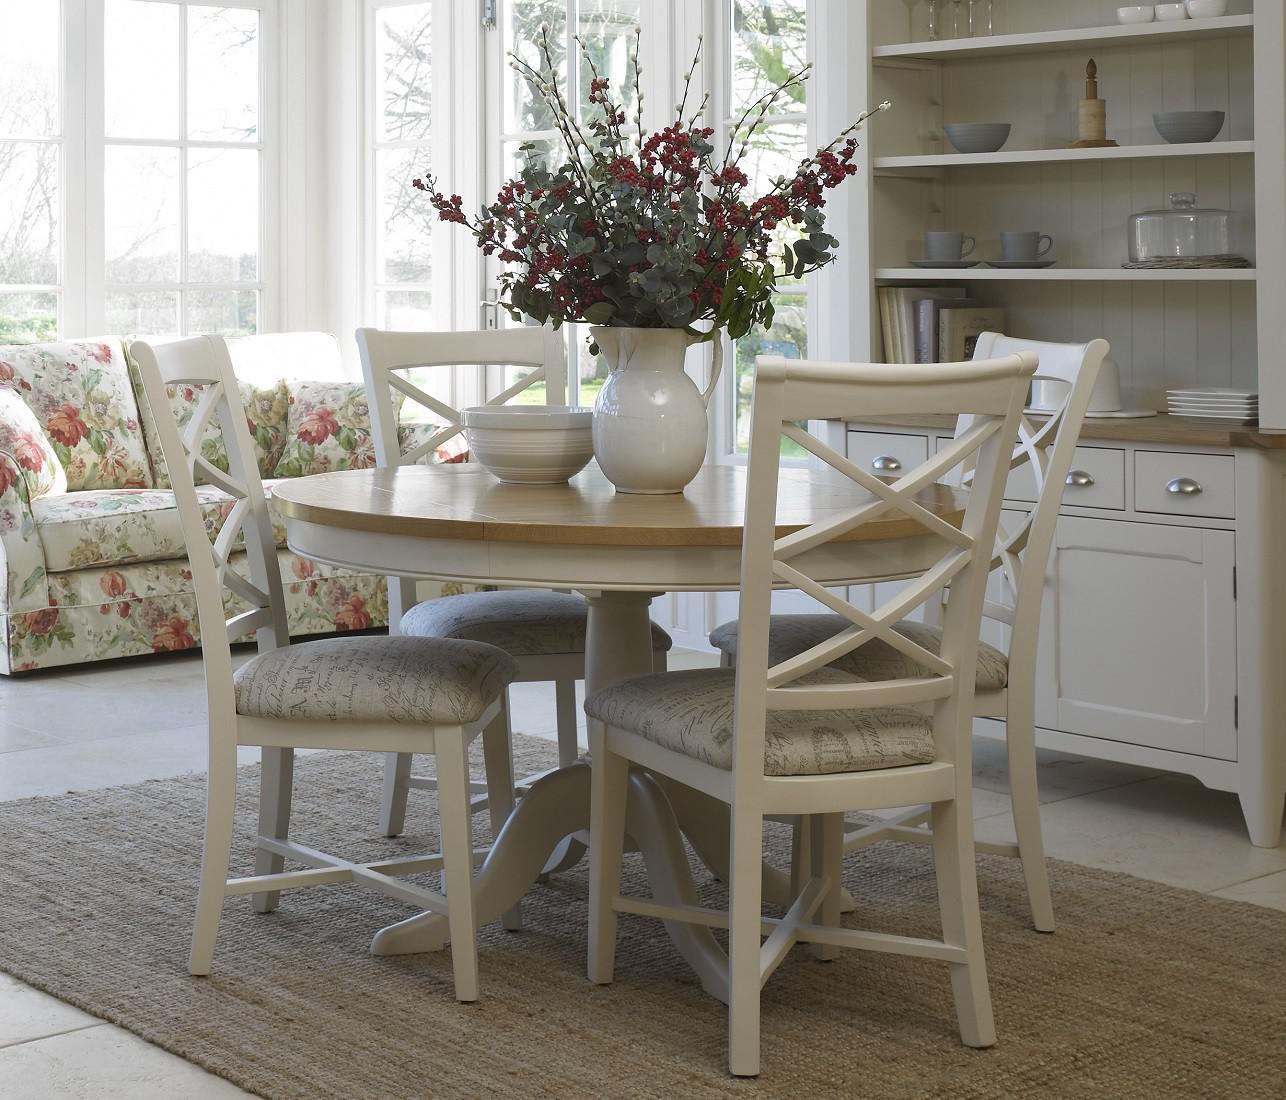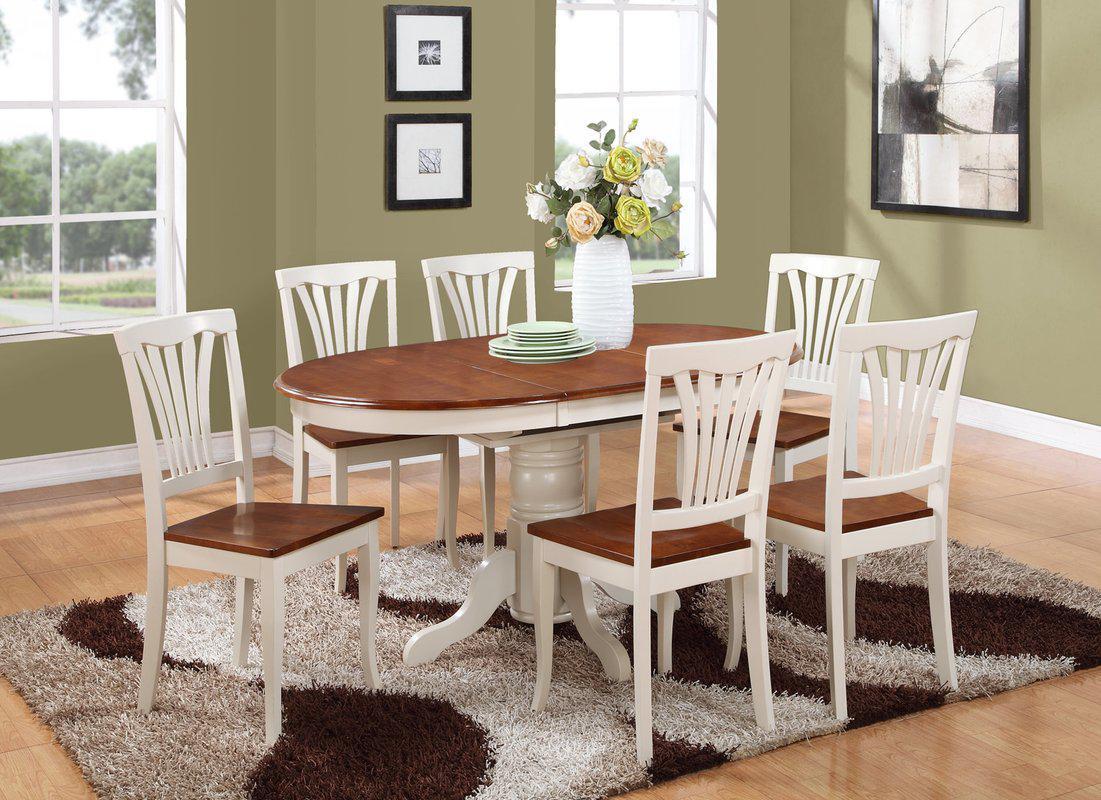The first image is the image on the left, the second image is the image on the right. Assess this claim about the two images: "One image shows white chairs around a round pedestal table, and the other shows white chairs around an oblong pedestal table.". Correct or not? Answer yes or no. Yes. The first image is the image on the left, the second image is the image on the right. Assess this claim about the two images: "A dining table in one image is round with four chairs, while a table in the second image is elongated and has six chairs.". Correct or not? Answer yes or no. Yes. 